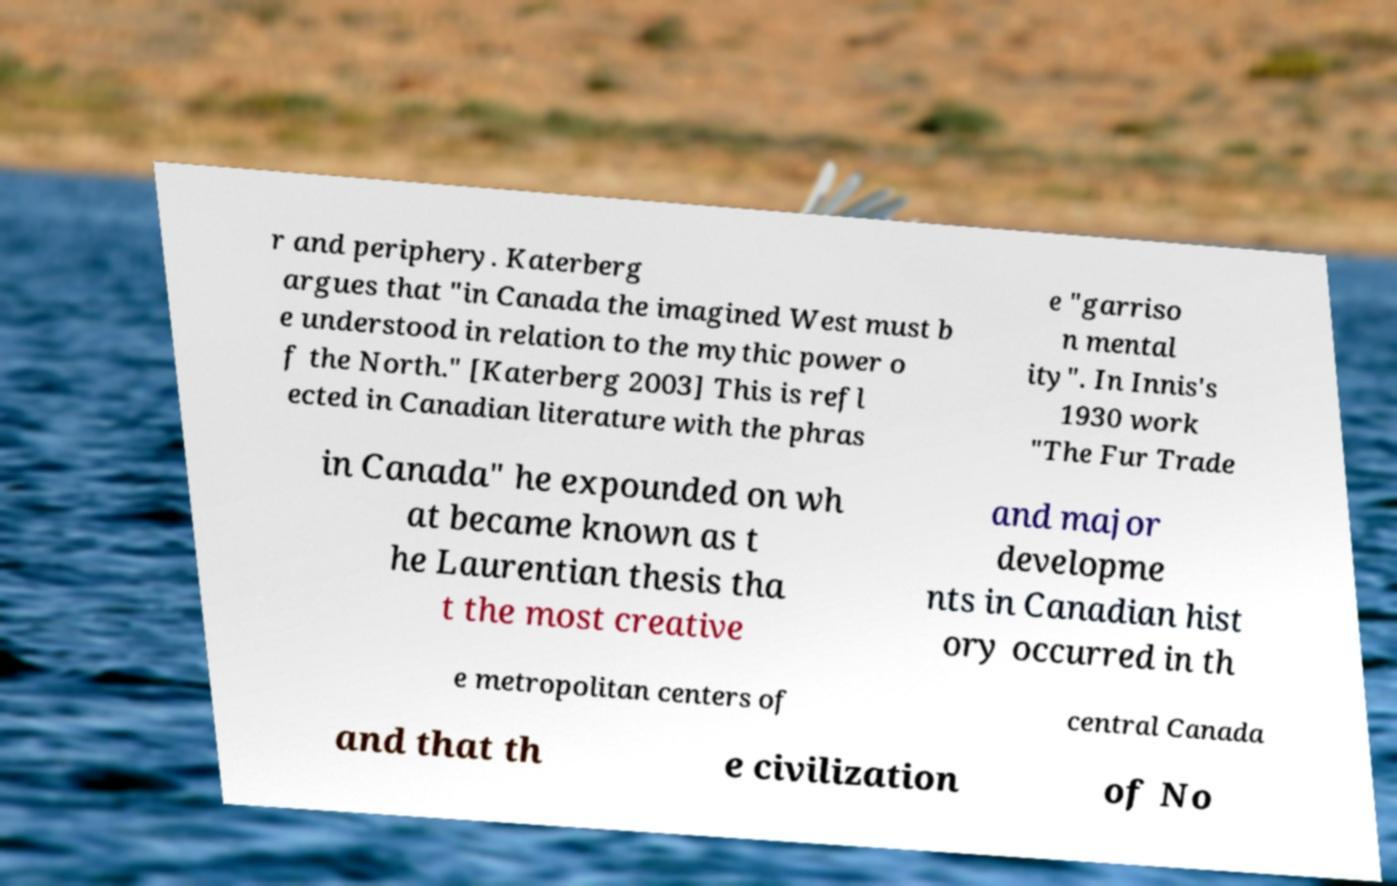Could you extract and type out the text from this image? r and periphery. Katerberg argues that "in Canada the imagined West must b e understood in relation to the mythic power o f the North." [Katerberg 2003] This is refl ected in Canadian literature with the phras e "garriso n mental ity". In Innis's 1930 work "The Fur Trade in Canada" he expounded on wh at became known as t he Laurentian thesis tha t the most creative and major developme nts in Canadian hist ory occurred in th e metropolitan centers of central Canada and that th e civilization of No 